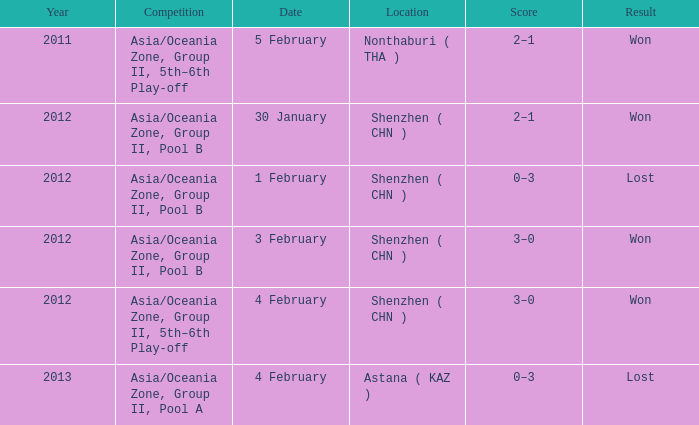What is the total of the year on february 5th? 2011.0. 